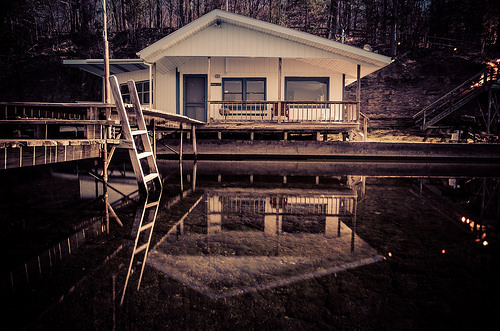<image>
Can you confirm if the house is behind the water? Yes. From this viewpoint, the house is positioned behind the water, with the water partially or fully occluding the house. 